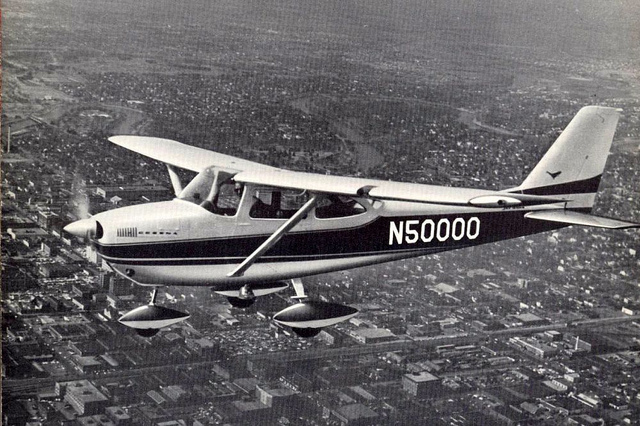Identify the text contained in this image. N50000 